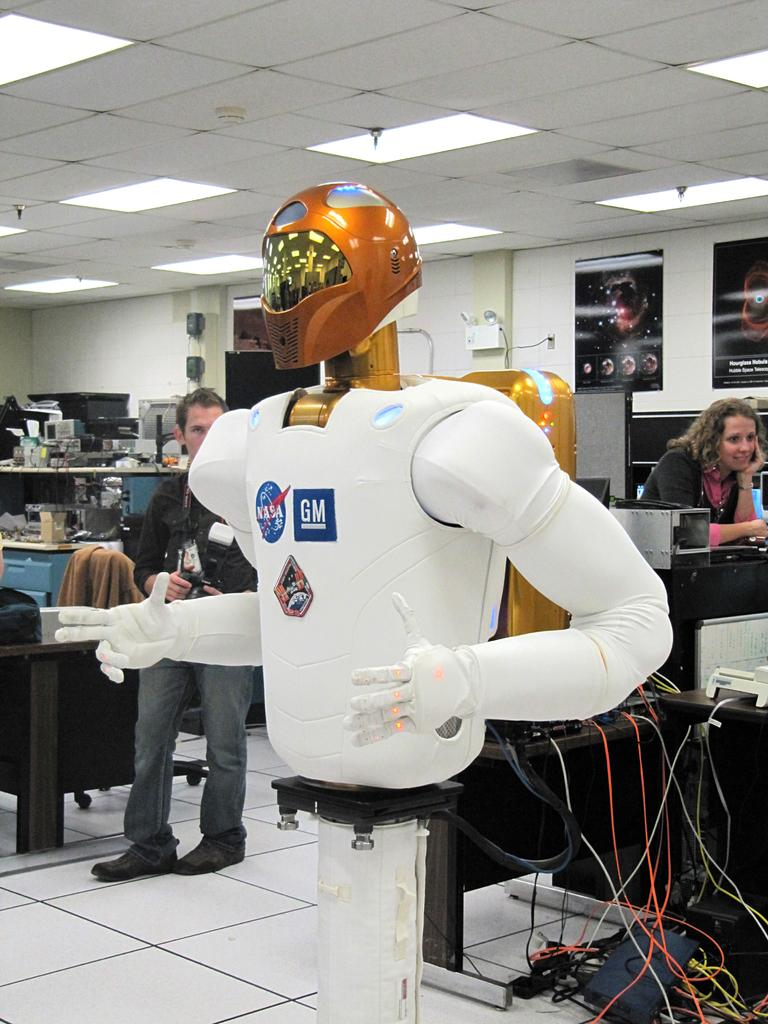What is the main subject of the image? There is a robot on a stand in the image. What else can be seen in the image besides the robot? There are wires visible in the image, as well as people, devices on tables, frames on a wall, and a roof with ceiling lights. Can you describe the people in the image? The provided facts do not give specific details about the people in the image. What type of devices are on the tables in the image? The provided facts do not specify the type of devices on the tables. What is the wealth of the committee in the image? There is no committee present in the image, and therefore no wealth can be attributed to it. 